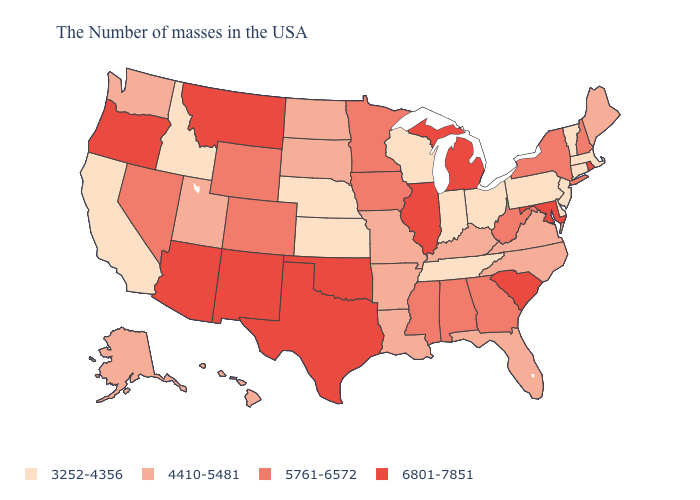Among the states that border Indiana , does Illinois have the highest value?
Short answer required. Yes. What is the value of North Dakota?
Short answer required. 4410-5481. What is the value of Maine?
Short answer required. 4410-5481. Name the states that have a value in the range 4410-5481?
Concise answer only. Maine, Virginia, North Carolina, Florida, Kentucky, Louisiana, Missouri, Arkansas, South Dakota, North Dakota, Utah, Washington, Alaska, Hawaii. What is the value of Illinois?
Quick response, please. 6801-7851. What is the lowest value in the USA?
Keep it brief. 3252-4356. What is the value of Wisconsin?
Quick response, please. 3252-4356. What is the value of Maine?
Write a very short answer. 4410-5481. What is the highest value in states that border Georgia?
Write a very short answer. 6801-7851. Among the states that border Connecticut , does New York have the highest value?
Give a very brief answer. No. Does New Jersey have the lowest value in the USA?
Give a very brief answer. Yes. What is the highest value in the USA?
Be succinct. 6801-7851. What is the value of Minnesota?
Concise answer only. 5761-6572. Among the states that border Colorado , which have the lowest value?
Answer briefly. Kansas, Nebraska. 